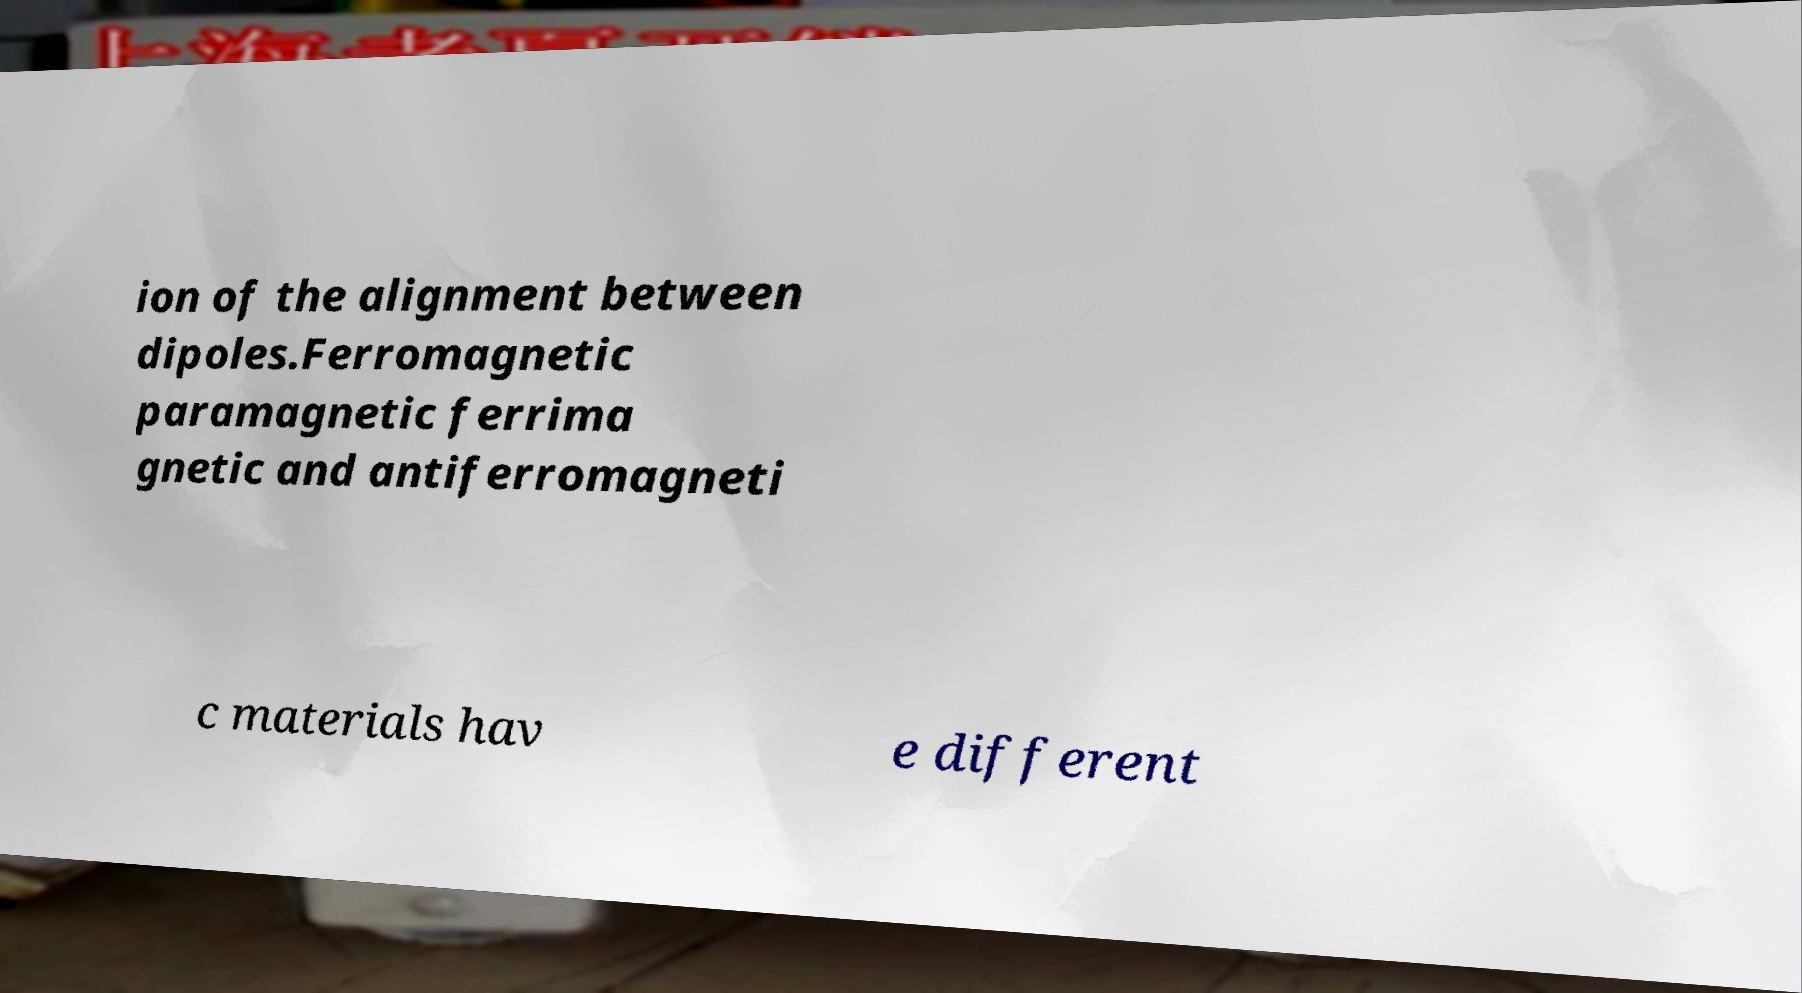Please identify and transcribe the text found in this image. ion of the alignment between dipoles.Ferromagnetic paramagnetic ferrima gnetic and antiferromagneti c materials hav e different 